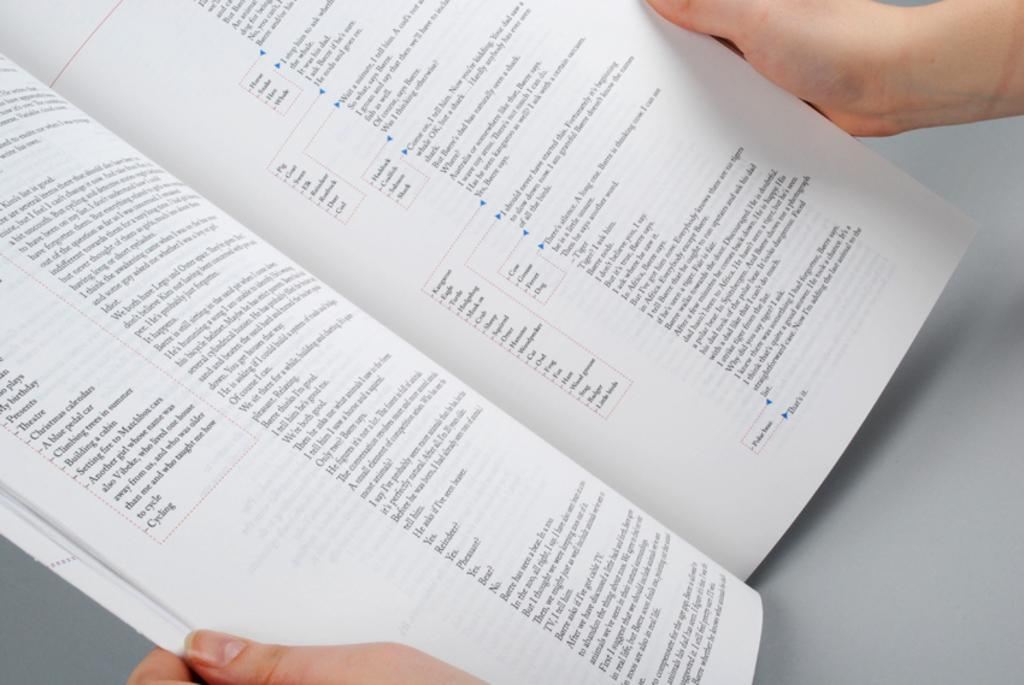What is the main subject of the image? There is a person in the image. What is the person holding in the image? The person is holding an open book. What type of mass can be seen in the image? There is no mass present in the image; it features a person holding an open book. Can you tell me how many cats are visible in the image? There are no cats present in the image. 